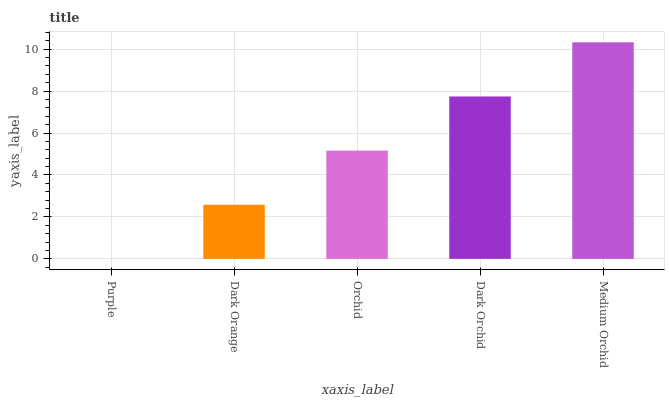Is Purple the minimum?
Answer yes or no. Yes. Is Medium Orchid the maximum?
Answer yes or no. Yes. Is Dark Orange the minimum?
Answer yes or no. No. Is Dark Orange the maximum?
Answer yes or no. No. Is Dark Orange greater than Purple?
Answer yes or no. Yes. Is Purple less than Dark Orange?
Answer yes or no. Yes. Is Purple greater than Dark Orange?
Answer yes or no. No. Is Dark Orange less than Purple?
Answer yes or no. No. Is Orchid the high median?
Answer yes or no. Yes. Is Orchid the low median?
Answer yes or no. Yes. Is Medium Orchid the high median?
Answer yes or no. No. Is Dark Orange the low median?
Answer yes or no. No. 